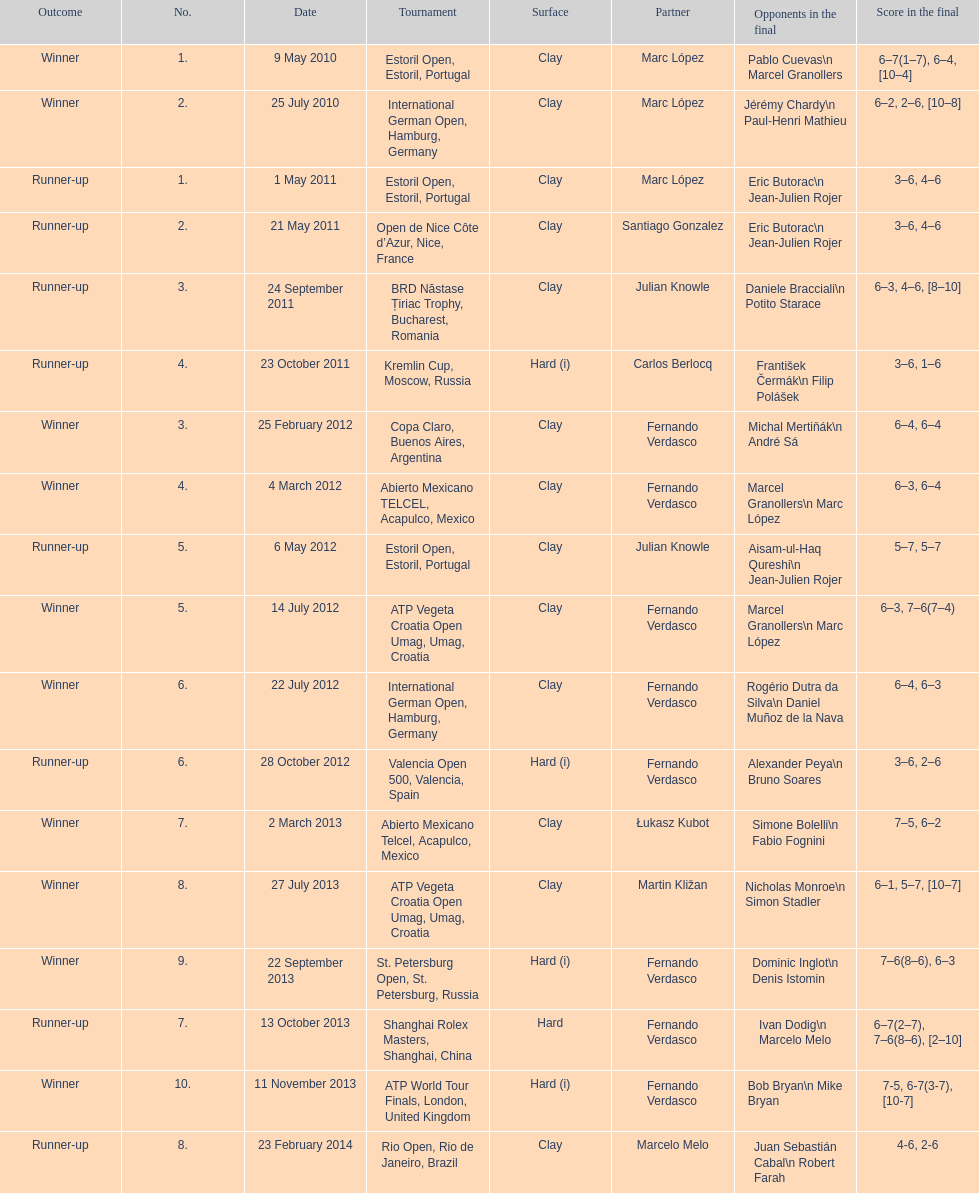How many winners are there? 10. 